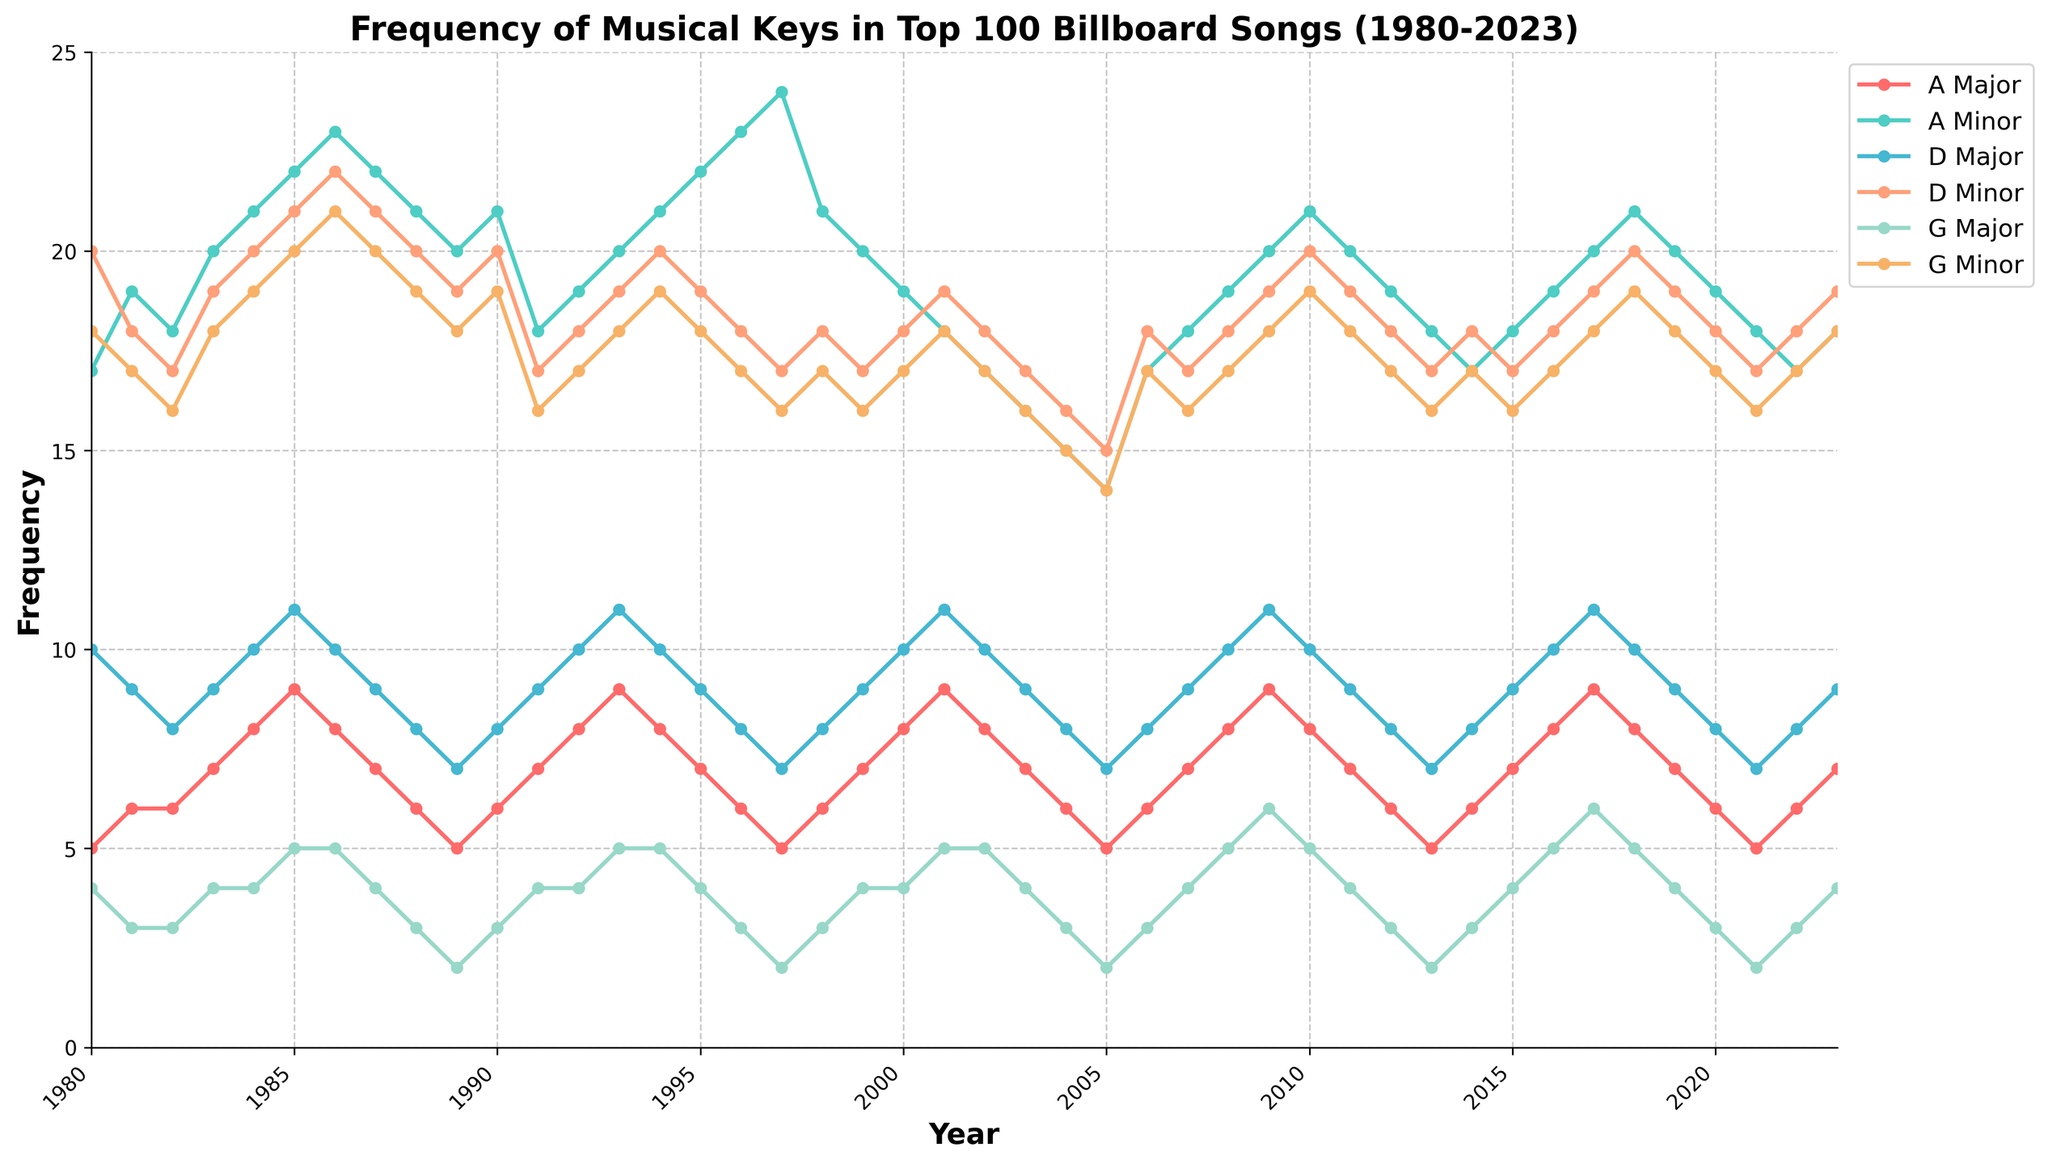What is the title of the figure? The title is at the top of the plot, usually in a larger font. It reads: 'Frequency of Musical Keys in Top 100 Billboard Songs (1980-2023)'
Answer: Frequency of Musical Keys in Top 100 Billboard Songs (1980-2023) What are the labels of the x-axis and y-axis? The x-axis label, found below the axis, is 'Year'. The y-axis label, found to the left of the axis, is 'Frequency'.
Answer: Year, Frequency What is the frequency of D Minor in the year 1985? Locate the 'D Minor' line which is color-coded, then find the intersection of this line with the 1985 vertical line. The y-axis value at this point represents the frequency.
Answer: 21 Which key has the highest frequency in 1984? Find the year 1984 on the x-axis, follow the vertical line upwards, and identify the line that reaches the highest point on the y-axis. This line correlates with 'D Minor'.
Answer: D Minor How many musical keys are plotted in the figure? Check the legend on the right-hand side of the plot, which displays the names of the musical keys being represented. Count these keys.
Answer: 6 Which musical key shows a decreasing trend from 1985 to 2023? Observe the slope of each key's line from the point marked 1985 to 2023. A decreasing trend means the line is going downwards on the right side. 'A Minor' shows this trend.
Answer: A Minor What was the average frequency of G Minor over the first five years in the dataset? Extract the frequencies of 'G Minor' from 1980 to 1984. Sum these values and divide by 5. (18 + 17 + 16 + 18 + 19) / 5 = 17.6.
Answer: 17.6 Compare the frequency of A Major in 1990 and 2000. Which year had a higher frequency? Identify the frequencies of 'A Major' in 1990 and 2000 by locating the respective points. Compare these values: 6 in 1990 and 8 in 2000. 2000 had a higher frequency.
Answer: 2000 What is the color used to represent E Major and how often does it appear in the legend? Look in the legend on the right side of the plot, where each key and its corresponding color are shown. E Major is represented in blue.
Answer: Blue Did the frequency of G Minor exceed 20 at any point between 1980 and 2023? Trace the line for 'G Minor' and see if it crosses the horizontal line marked 20 on the y-axis at any x-axis points. It does not exceed 20 at any point.
Answer: No 